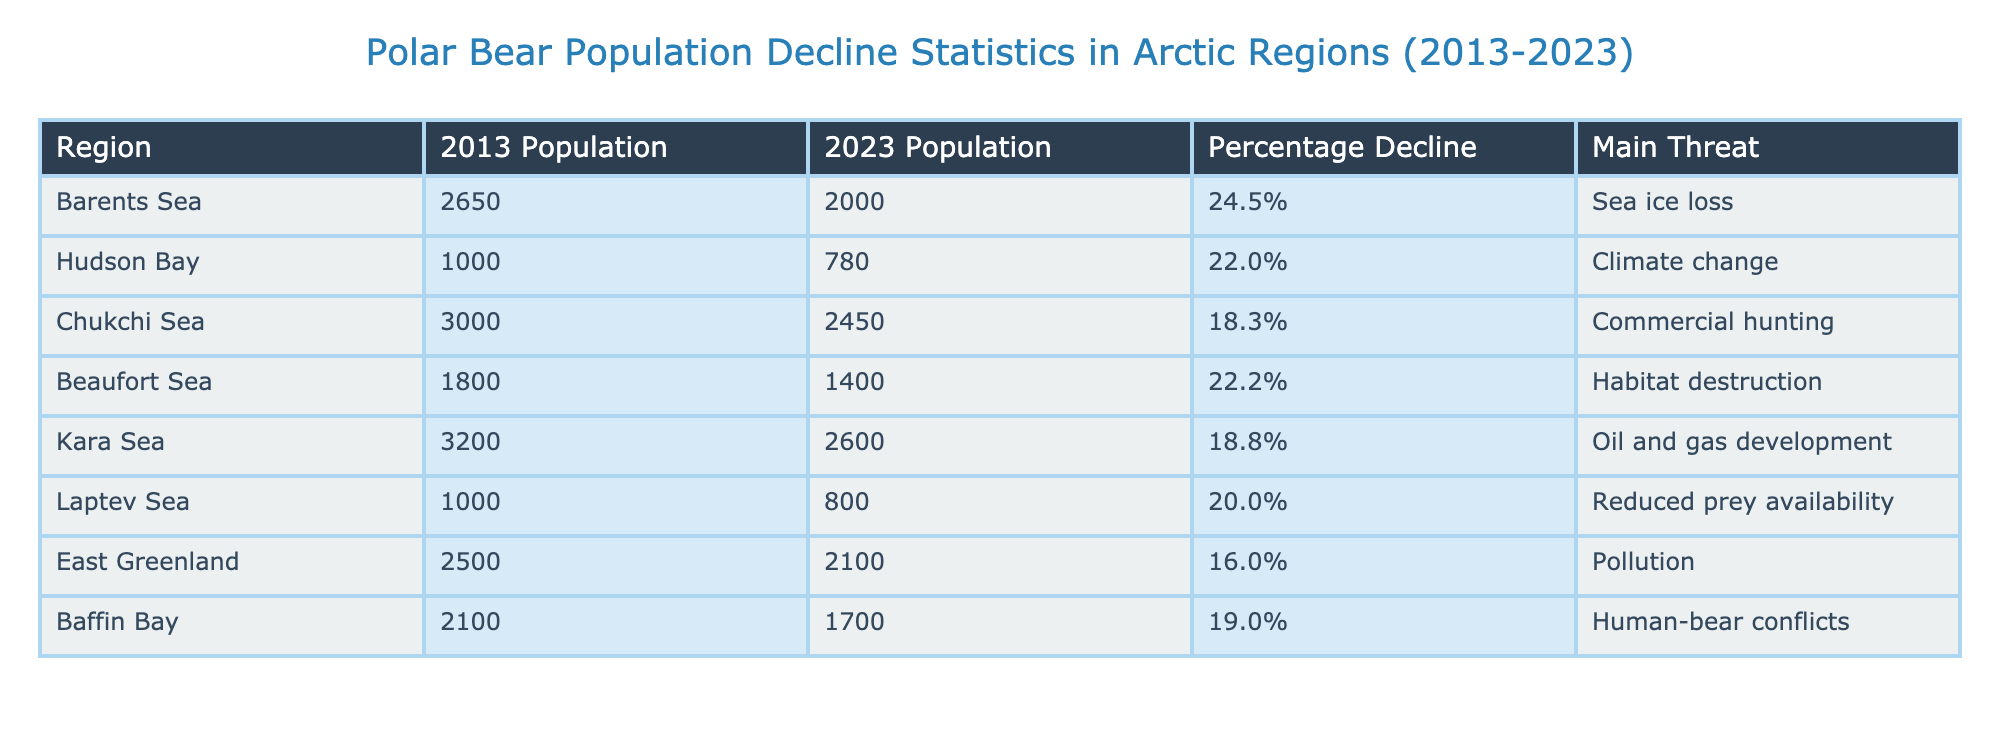What is the percentage decline in the population of polar bears in the Barents Sea? The table shows that in the Barents Sea, the population declined from 2650 in 2013 to 2000 in 2023. The percentage decline is explicitly stated in the "Percentage Decline" column as 24.5%.
Answer: 24.5% Which region experienced the highest percentage decline in polar bear population? Looking at the "Percentage Decline" column, the highest figure is for the Barents Sea at 24.5%.
Answer: Barents Sea What was the population of polar bears in Hudson Bay in 2013? The "2013 Population" column for Hudson Bay shows a value of 1000.
Answer: 1000 What is the average percentage decline of the polar bear populations across all regions listed in the table? Adding the percentage declines: 24.5% + 22.0% + 18.3% + 22.2% + 18.8% + 20.0% + 16.0% + 19.0% =  181.8%. Dividing this total by the 8 regions gives an average of 181.8% / 8 = 22.725%.
Answer: 22.725% Is it true that the Chukchi Sea had a population decline of less than 20%? From the table, the Chukchi Sea's population decline is listed as 18.3%. Since 18.3% is less than 20%, the statement is true.
Answer: Yes What is the main threat faced by the polar bears in the Beaufort Sea? The "Main Threat" column for the Beaufort Sea identifies habitat destruction as the primary threat.
Answer: Habitat destruction If the Kara Sea had a population of 3200 in 2013, how many polar bears have been lost in the last decade? The population in 2023 is 2600, so the number of polar bears lost is calculated by subtracting the current population from the past population: 3200 - 2600 = 600.
Answer: 600 How does the population of polar bears in East Greenland compare to the population in Hudson Bay in 2023? The populations in 2023 are 2100 in East Greenland and 780 in Hudson Bay. Thus, East Greenland has significantly more polar bears than Hudson Bay.
Answer: East Greenland has more polar bears 